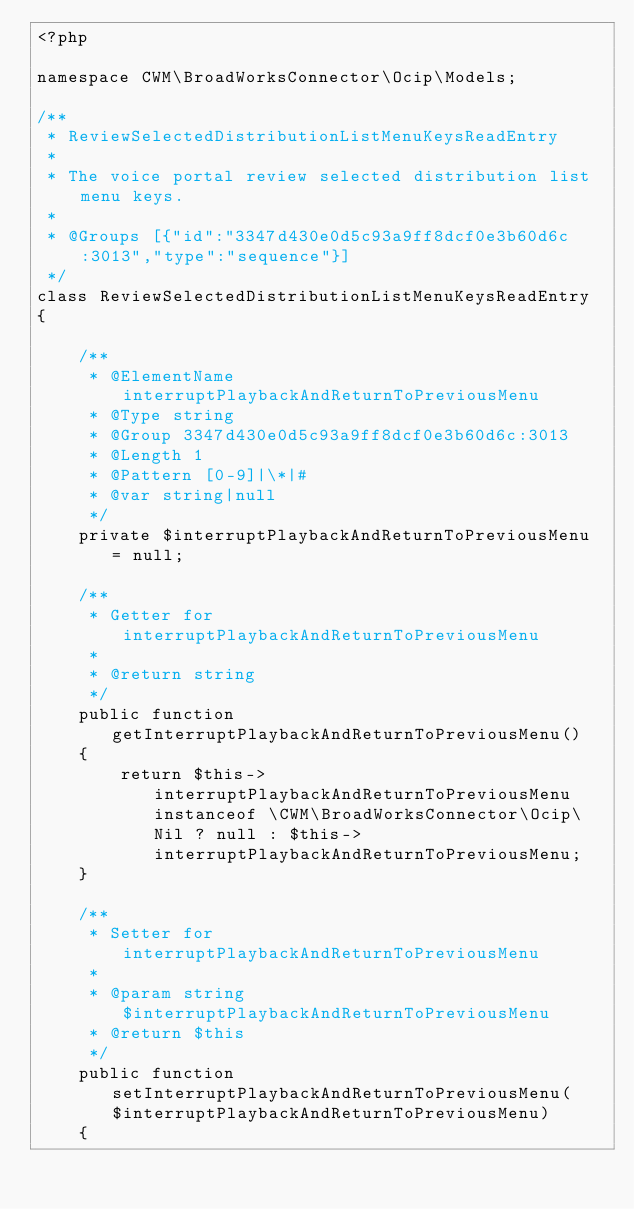Convert code to text. <code><loc_0><loc_0><loc_500><loc_500><_PHP_><?php

namespace CWM\BroadWorksConnector\Ocip\Models;

/**
 * ReviewSelectedDistributionListMenuKeysReadEntry
 *
 * The voice portal review selected distribution list menu keys.
 *
 * @Groups [{"id":"3347d430e0d5c93a9ff8dcf0e3b60d6c:3013","type":"sequence"}]
 */
class ReviewSelectedDistributionListMenuKeysReadEntry
{

    /**
     * @ElementName interruptPlaybackAndReturnToPreviousMenu
     * @Type string
     * @Group 3347d430e0d5c93a9ff8dcf0e3b60d6c:3013
     * @Length 1
     * @Pattern [0-9]|\*|#
     * @var string|null
     */
    private $interruptPlaybackAndReturnToPreviousMenu = null;

    /**
     * Getter for interruptPlaybackAndReturnToPreviousMenu
     *
     * @return string
     */
    public function getInterruptPlaybackAndReturnToPreviousMenu()
    {
        return $this->interruptPlaybackAndReturnToPreviousMenu instanceof \CWM\BroadWorksConnector\Ocip\Nil ? null : $this->interruptPlaybackAndReturnToPreviousMenu;
    }

    /**
     * Setter for interruptPlaybackAndReturnToPreviousMenu
     *
     * @param string $interruptPlaybackAndReturnToPreviousMenu
     * @return $this
     */
    public function setInterruptPlaybackAndReturnToPreviousMenu($interruptPlaybackAndReturnToPreviousMenu)
    {</code> 